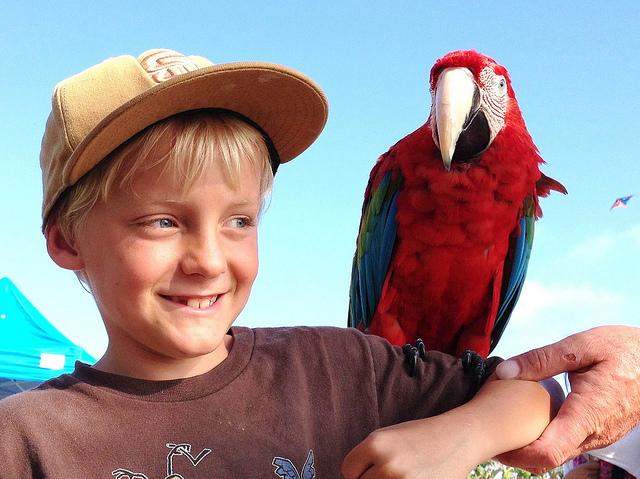What letter is on the boys hat?
Answer briefly. S. Who is holding the boy?
Be succinct. Man. What does the man have around his head?
Give a very brief answer. Hat. What is the main color of the bird?
Short answer required. Red. 